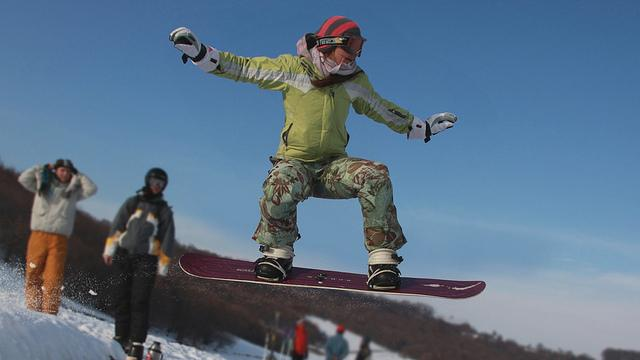Why are there straps on snowboards?

Choices:
A) law
B) support/response
C) style
D) security support/response 